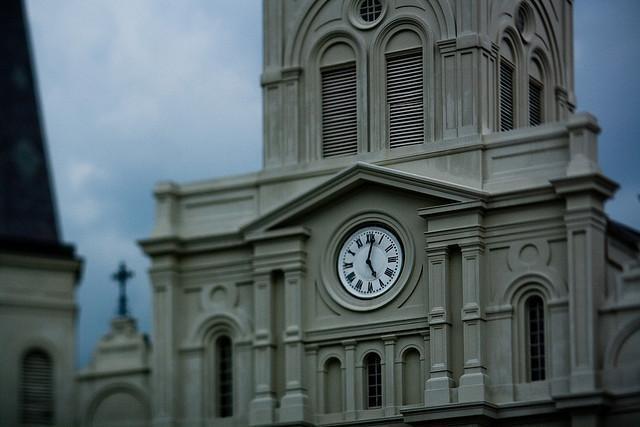How many clocks?
Give a very brief answer. 1. 